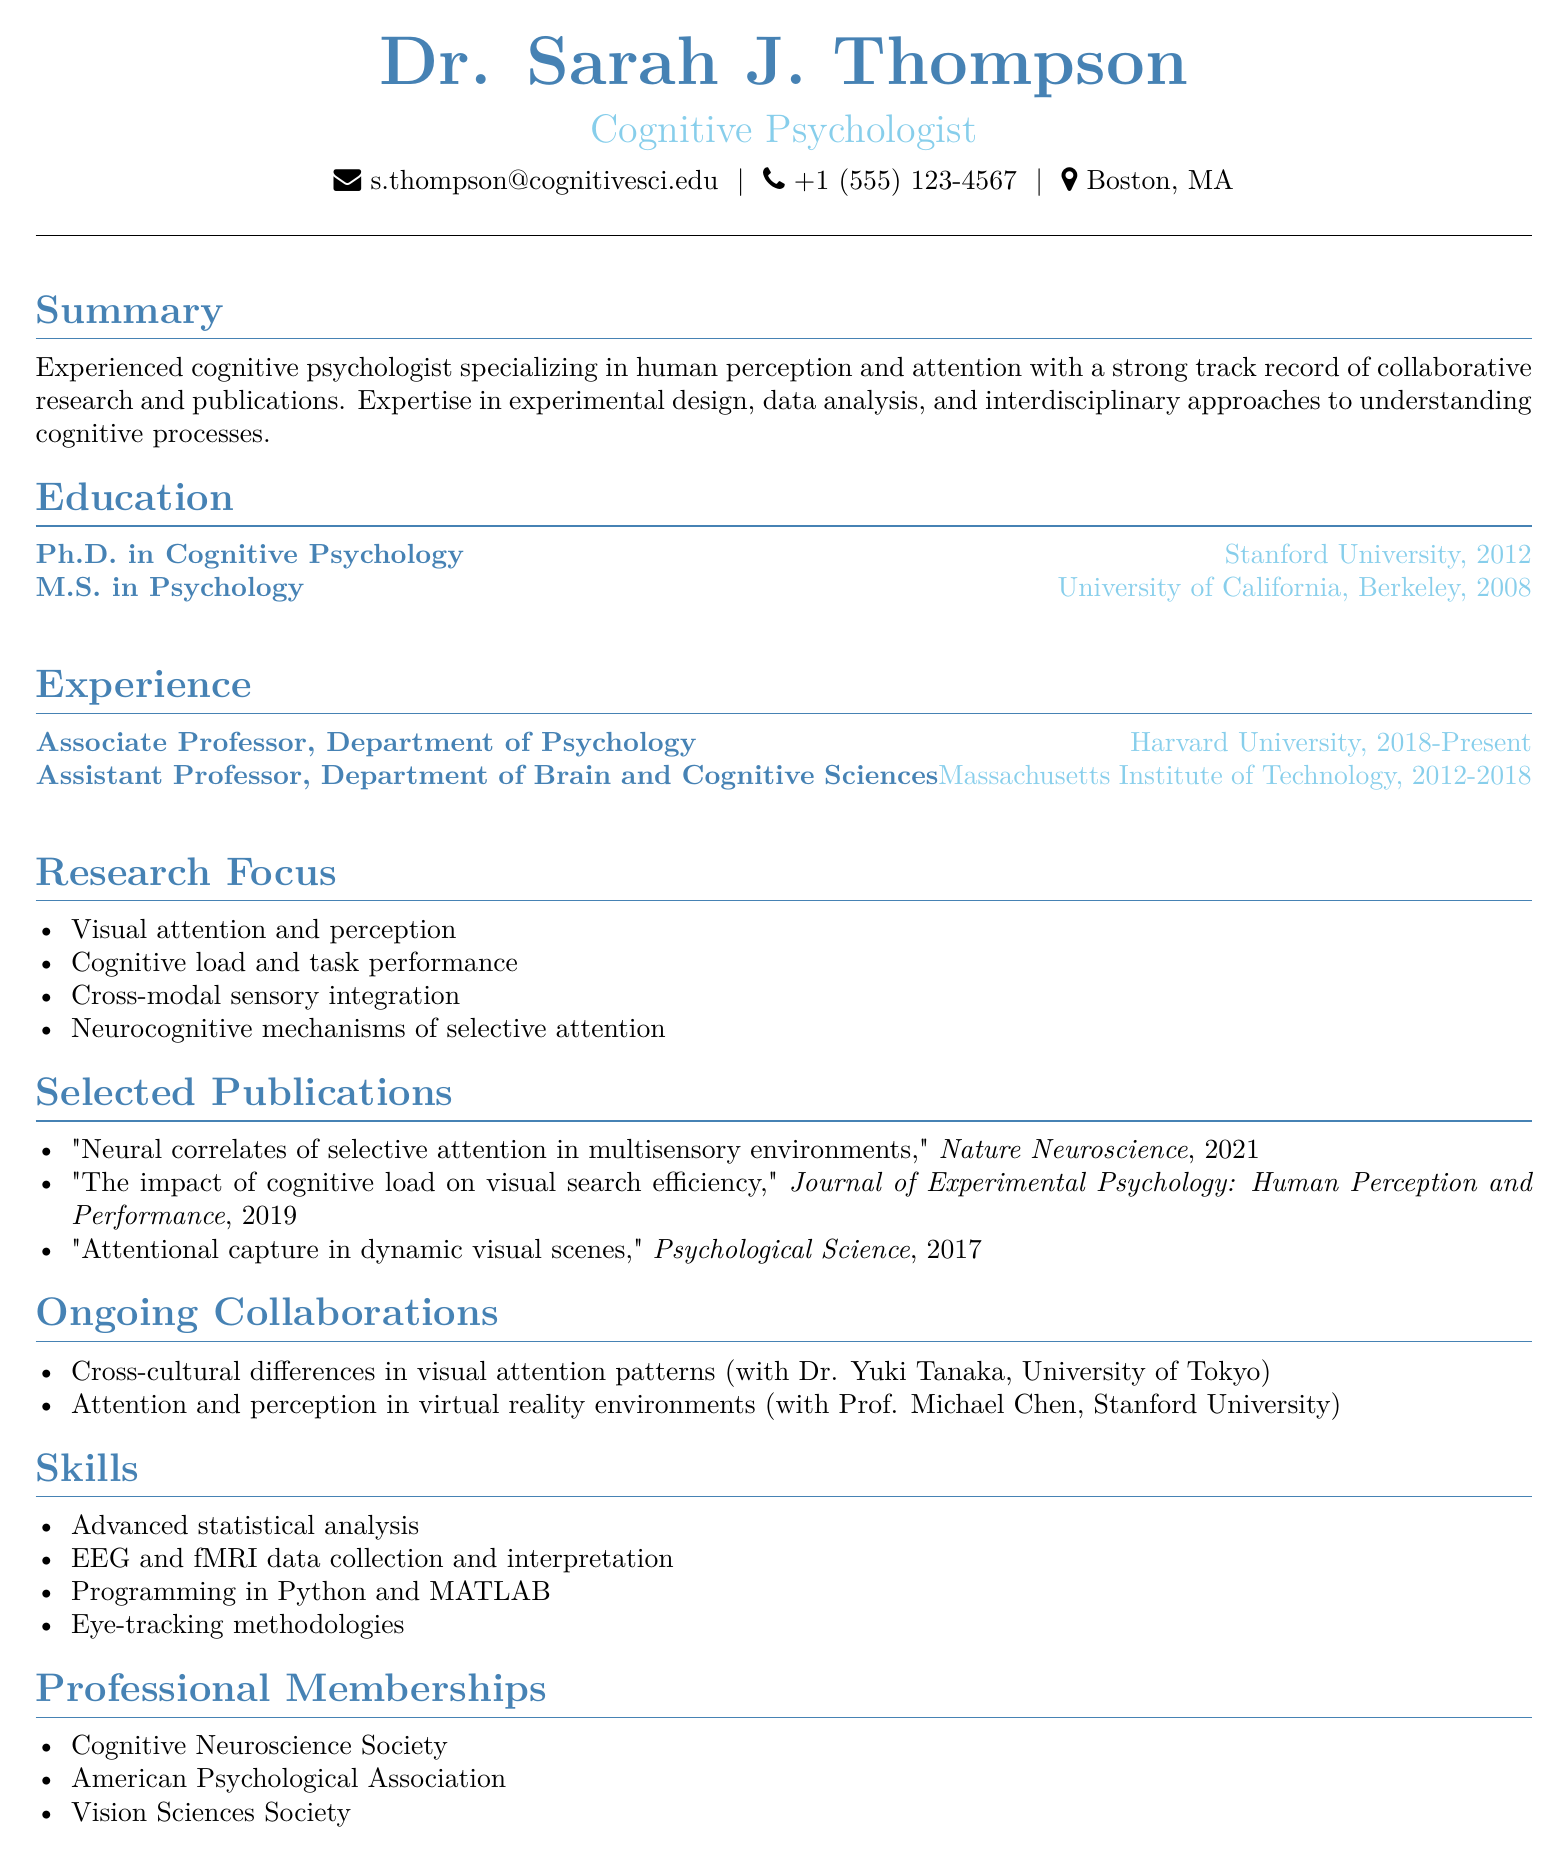What is the name of the cognitive psychologist? The name of the cognitive psychologist is listed in the personal information section of the document.
Answer: Dr. Sarah J. Thompson What is the email address provided? The email address is found in the personal information section of the document.
Answer: s.thompson@cognitivesci.edu What is the highest degree earned by Dr. Sarah J. Thompson? The highest degree is indicated in the education section, highlighting the most advanced qualification.
Answer: Ph.D. in Cognitive Psychology In which year did Dr. Thompson complete her Ph.D.? The year of the Ph.D. completion is mentioned in the education section.
Answer: 2012 What is one of the research focuses related to visual perception? The research focus can be found in the research focus section, specifying areas of expertise.
Answer: Visual attention and perception Which journal published the paper on cognitive load and visual search efficiency? The journal name is provided in the selected publications section alongside the publication details.
Answer: Journal of Experimental Psychology: Human Perception and Performance Who is collaborating with Dr. Thompson on virtual reality environments? The collaborator's name is mentioned in the ongoing collaborations section of the document.
Answer: Prof. Michael Chen What role does Dr. Thompson hold at Harvard University? The role is specified in the experience section, indicating her current professional position.
Answer: Associate Professor Which society is Dr. Thompson a member of? The professional memberships section lists various organizations Dr. Thompson belongs to.
Answer: Cognitive Neuroscience Society 